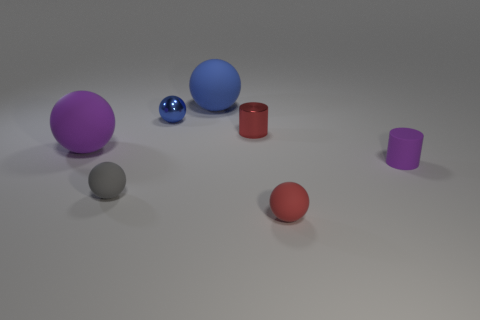Are there any tiny metal spheres?
Ensure brevity in your answer.  Yes. How many other things are there of the same material as the gray thing?
Provide a succinct answer. 4. There is a red cylinder that is the same size as the metallic ball; what is it made of?
Provide a succinct answer. Metal. There is a small red object in front of the gray object; is its shape the same as the blue shiny object?
Offer a very short reply. Yes. How many things are either large balls that are behind the red metallic thing or purple metal blocks?
Your answer should be very brief. 1. What is the shape of the purple rubber thing that is the same size as the red shiny thing?
Your answer should be very brief. Cylinder. There is a purple rubber object that is to the left of the tiny purple rubber thing; is its size the same as the cylinder behind the purple matte cylinder?
Provide a short and direct response. No. The tiny cylinder that is the same material as the big blue thing is what color?
Give a very brief answer. Purple. Are the small ball to the right of the tiny red cylinder and the red object that is behind the small gray matte ball made of the same material?
Provide a succinct answer. No. Is there a red ball that has the same size as the red cylinder?
Make the answer very short. Yes. 